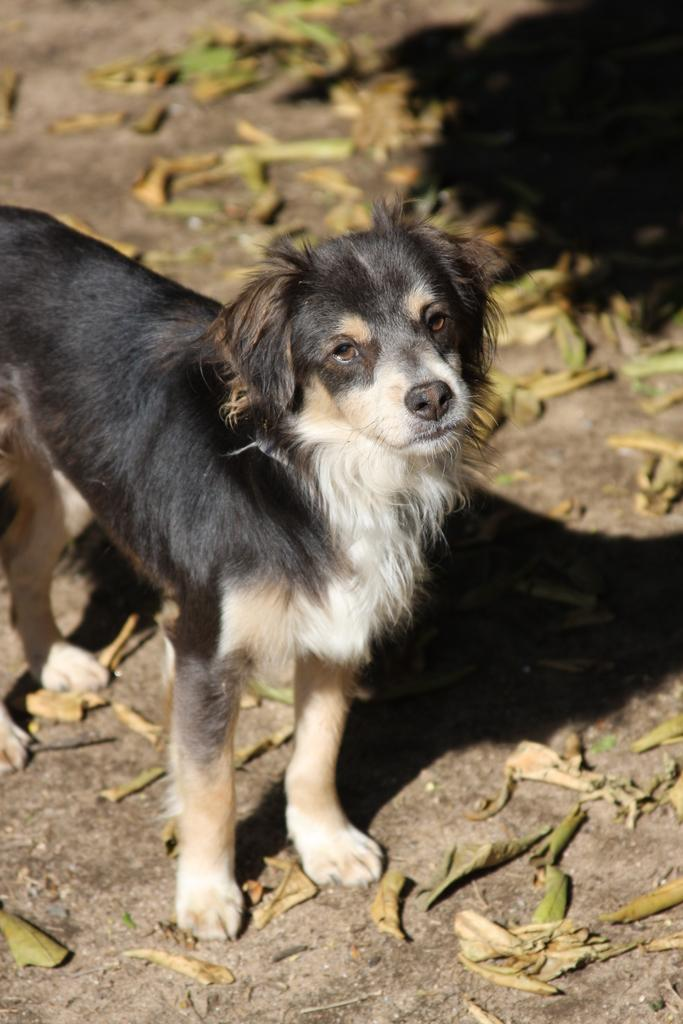What animal is present in the image? There is a dog in the image. On which side of the image is the dog located? The dog is on the left side of the image. What color scheme is used for the dog in the image? The dog is in black and white colors. What surface is the dog standing on? The dog is standing on the ground. What type of vegetation is present around the dog? There are leaves around the dog. What type of grape is the dog eating in the image? There is no grape present in the image, and the dog is not eating anything. What theory does the dog have about the leaves around it? The image does not provide any information about the dog's thoughts or theories, so we cannot determine what theory the dog might have about the leaves. 